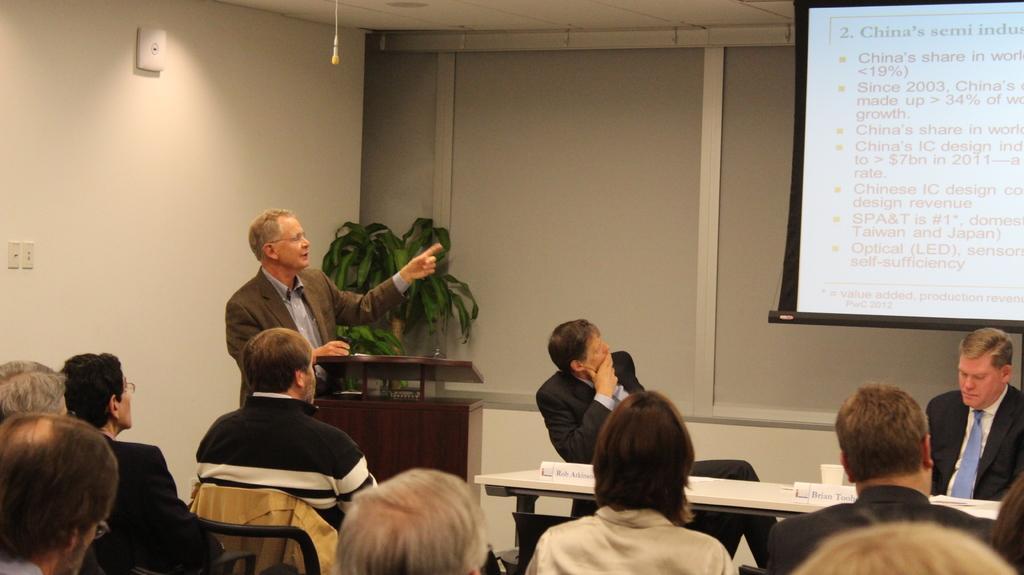Could you give a brief overview of what you see in this image? In this image, we can see people sitting on the chairs and one of them is standing and we can see a podium and there are boards and a cup on the table. In the background, there is a screen and some text and there are some other objects on the wall and there is a plant. 